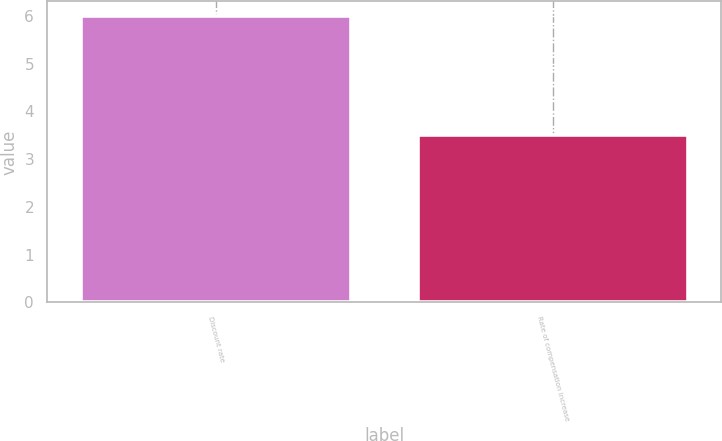Convert chart. <chart><loc_0><loc_0><loc_500><loc_500><bar_chart><fcel>Discount rate<fcel>Rate of compensation increase<nl><fcel>6<fcel>3.5<nl></chart> 